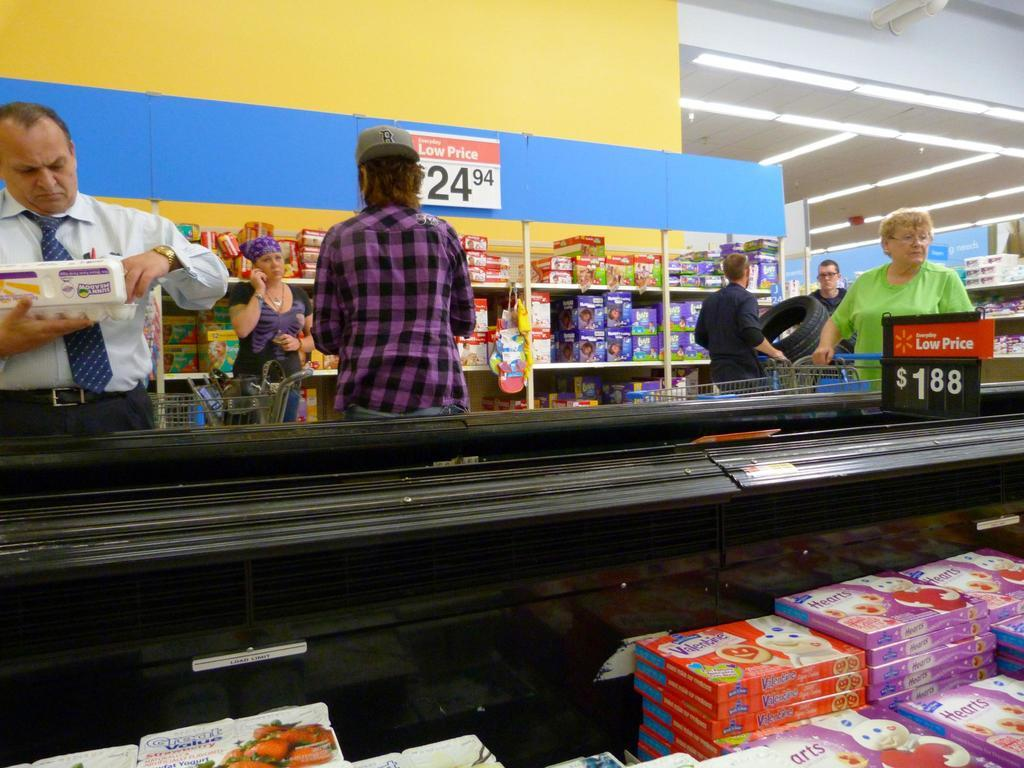<image>
Share a concise interpretation of the image provided. A group of shoppers at Walmart looking at items costing a new Low Price of 24.94 